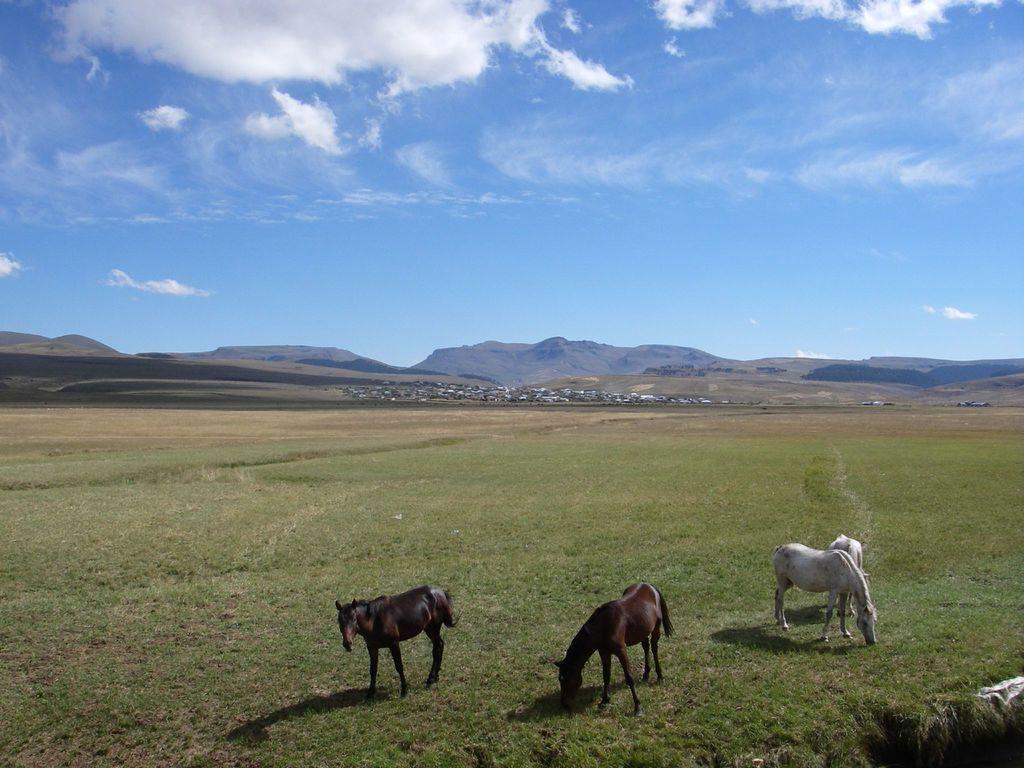Can you describe this image briefly? In this picture we can see the horses. In the background of the image we can see the hills, grass, stones. At the bottom of the image we can see the ground. At the top of the image we can see the clouds are present in the sky. 